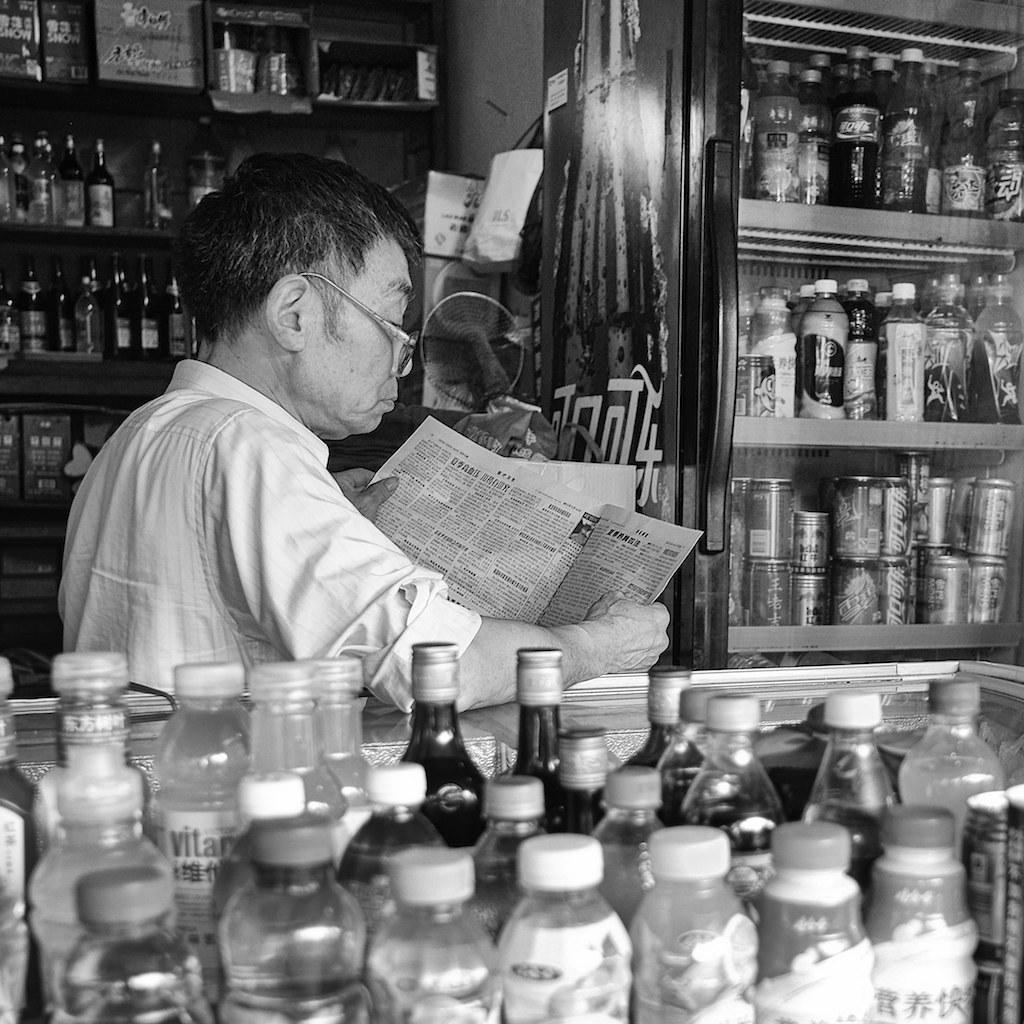Who is present in the image? There is a man in the image. Where is the man located? The man is sitting in a store. What is the man doing in the image? The man is reading a newspaper. What type of lunch is the man eating in the image? There is no lunch present in the image; the man is reading a newspaper. What kind of leaf is the man holding in the image? There is no leaf present in the image; the man is reading a newspaper. 